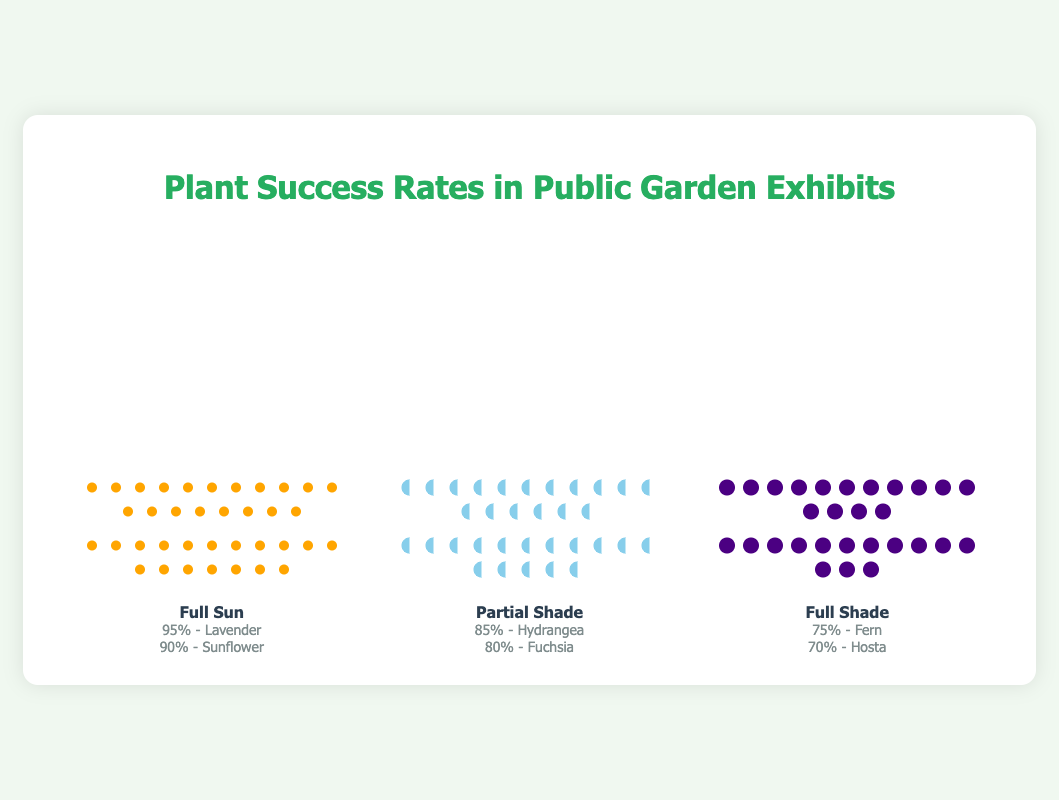What are the plant success rates for 'Full Sun' category? Referring to the figure, we can see icons and percentages next to each plant under the 'Full Sun' column. Lavender has a success rate of 95% and Sunflower has a success rate of 90%.
Answer: Lavender: 95%, Sunflower: 90% Which plant has the highest success rate in 'Partial Shade'? By looking at the 'Partial Shade' column, we note the success rates: Hydrangea at 85% and Fuchsia at 80%. Thus, the highest success rate is for Hydrangea.
Answer: Hydrangea Which light condition has the plant with the lowest success rate? By comparing the success rates for each light condition, we see that the lowest rates are Hosta in Full Shade at 70%, Fuchsia in Partial Shade at 80%, and Sunflower in Full Sun at 90%. Thus, Full Shade has the lowest success rate plant.
Answer: Full Shade How does the success rate of Fern compare to Lavender? The success rate of Fern is 75% while Lavender has a success rate of 95%. To compare, we subtract Fern's rate from Lavender's (95% - 75%). Therefore, Lavender's success rate is higher by 20%.
Answer: Lavender's success rate is higher by 20% How many plants in total were surveyed for 'Full Sun' and 'Partial Shade' combined? In the 'Full Sun' column, there are 19 icons for Lavender and 18 icons for Sunflower, totaling 37 plants. In the 'Partial Shade' column, there are 17 icons for Hydrangea and 16 icons for Fuchsia, totaling 33 plants. Combined, this is 37 + 33, resulting in 70 plants.
Answer: 70 plants What is the average success rate of plants in 'Full Shade'? The success rates for Full Shade are 75% for Fern and 70% for Hosta. The average is calculated as (75% + 70%) / 2, which equals 72.5%.
Answer: 72.5% Which light category has the highest overall average success rate? Calculate the average success rate for each category. 
Full Sun: (95% + 90%) / 2 = 92.5%.
Partial Shade: (85% + 80%) / 2 = 82.5%.
Full Shade: (75% + 70%) / 2 = 72.5%.
From these calculations, Full Sun has the highest average success rate.
Answer: Full Sun Which plant has the second-lowest success rate and what is it? From the success rates listed, Hosta has the lowest at 70%, and Fern is next at 75%. Therefore, the second-lowest success rate belongs to Fern.
Answer: Fern, 75% 